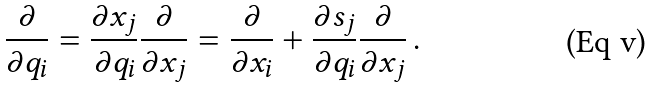<formula> <loc_0><loc_0><loc_500><loc_500>\frac { \partial } { \partial q _ { i } } = \frac { \partial x _ { j } } { \partial q _ { i } } \frac { \partial } { \partial x _ { j } } = \frac { \partial } { \partial x _ { i } } + \frac { \partial s _ { j } } { \partial q _ { i } } \frac { \partial } { \partial x _ { j } } \, .</formula> 